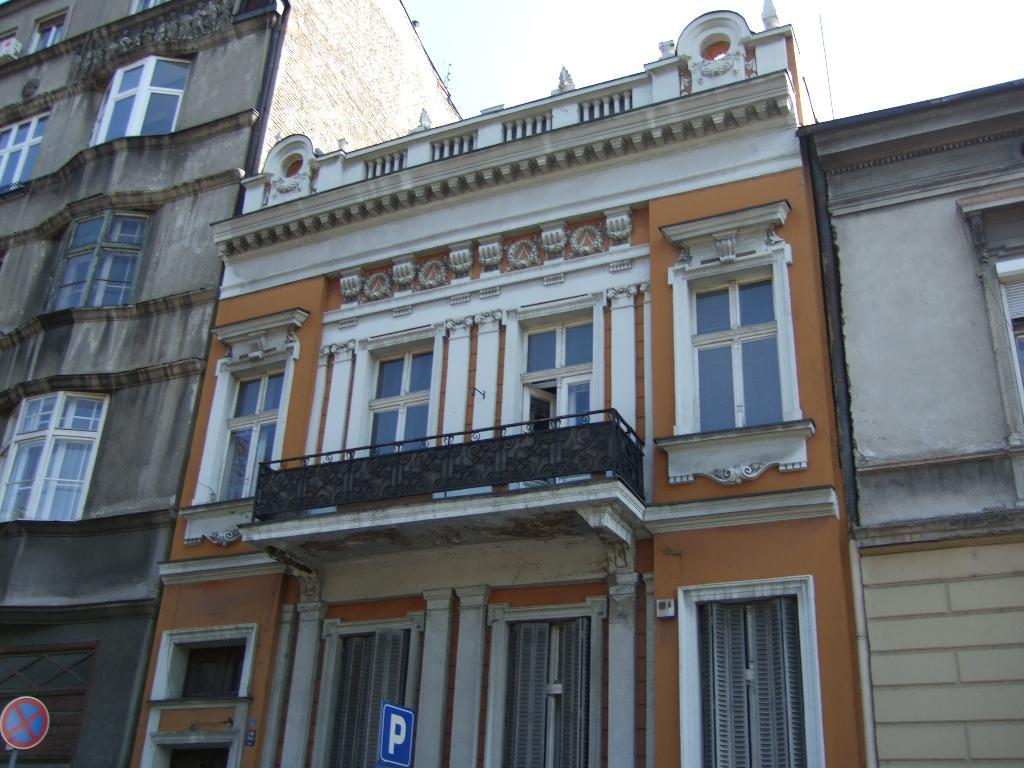What type of structures are present in the image? There are buildings in the image. What features can be seen on the buildings? The buildings have doors and windows. Are there any signs or notices visible in the image? Yes, there are precaution boards attached to poles in the image. What is the condition of the sky in the image? The sky is clear in the image. What type of songs can be heard coming from the baby in the image? There is no baby present in the image, so it's not possible to determine what, if any, songs might be heard. 